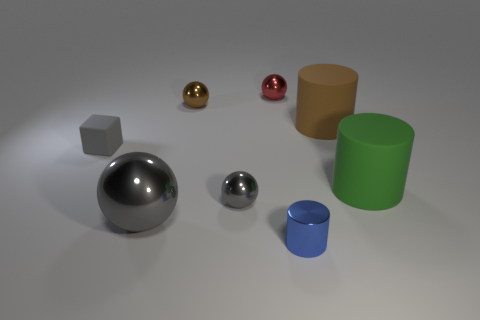Subtract 1 balls. How many balls are left? 3 Subtract all brown metallic spheres. How many spheres are left? 3 Subtract all yellow balls. Subtract all gray cubes. How many balls are left? 4 Add 1 large balls. How many objects exist? 9 Subtract all cylinders. How many objects are left? 5 Add 6 gray objects. How many gray objects are left? 9 Add 4 tiny red shiny blocks. How many tiny red shiny blocks exist? 4 Subtract 0 purple blocks. How many objects are left? 8 Subtract all green things. Subtract all red metallic things. How many objects are left? 6 